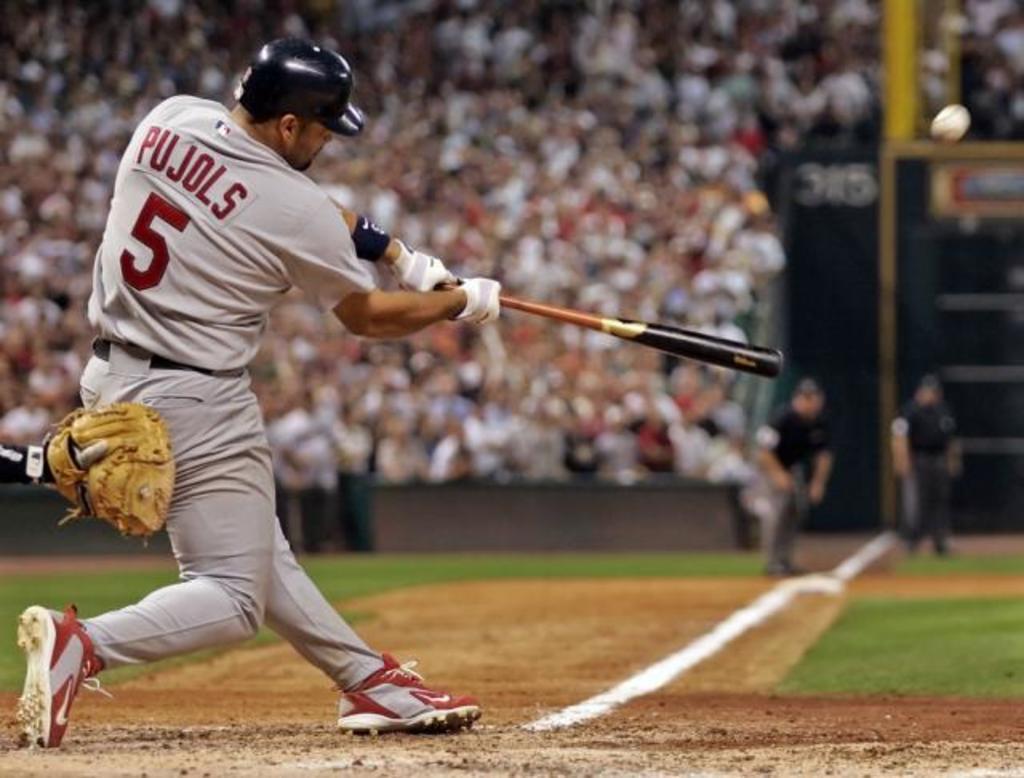What's the batter's last name?
Ensure brevity in your answer.  Pujols. What is the pujols' number?
Give a very brief answer. 5. 